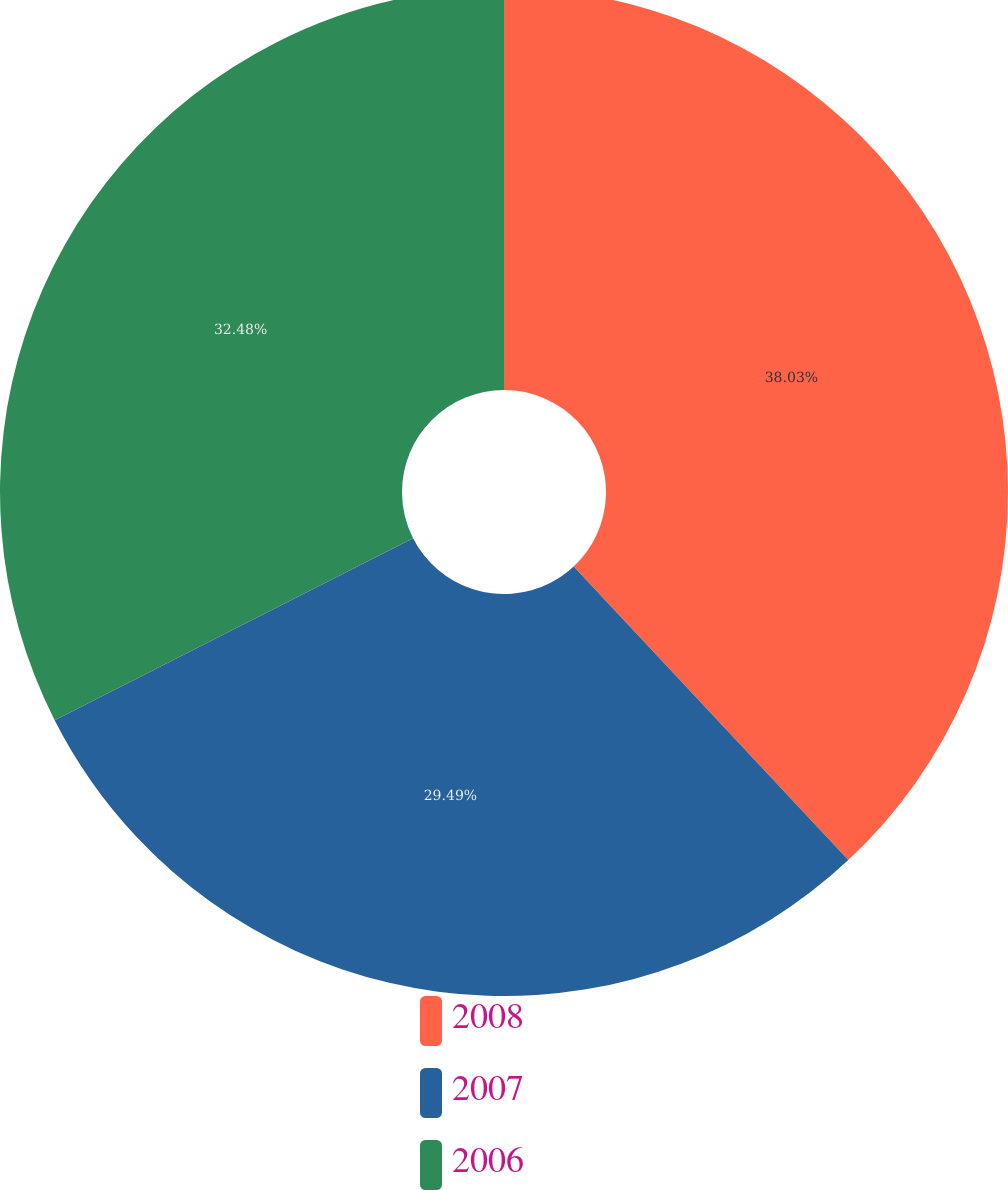Convert chart. <chart><loc_0><loc_0><loc_500><loc_500><pie_chart><fcel>2008<fcel>2007<fcel>2006<nl><fcel>38.03%<fcel>29.49%<fcel>32.48%<nl></chart> 